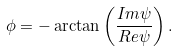Convert formula to latex. <formula><loc_0><loc_0><loc_500><loc_500>\phi = - \arctan \left ( \frac { I m \psi } { R e \psi } \right ) .</formula> 